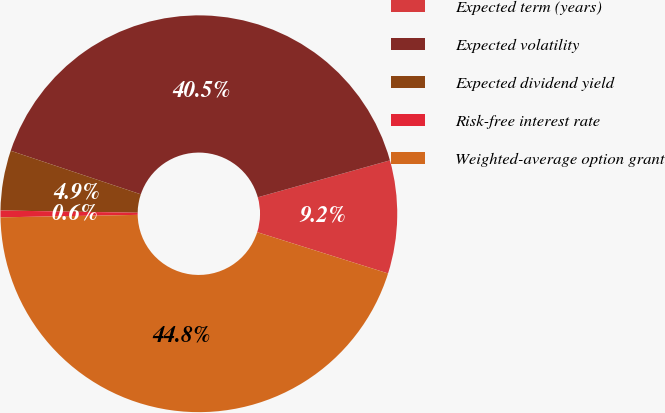Convert chart to OTSL. <chart><loc_0><loc_0><loc_500><loc_500><pie_chart><fcel>Expected term (years)<fcel>Expected volatility<fcel>Expected dividend yield<fcel>Risk-free interest rate<fcel>Weighted-average option grant<nl><fcel>9.2%<fcel>40.52%<fcel>4.88%<fcel>0.55%<fcel>44.85%<nl></chart> 